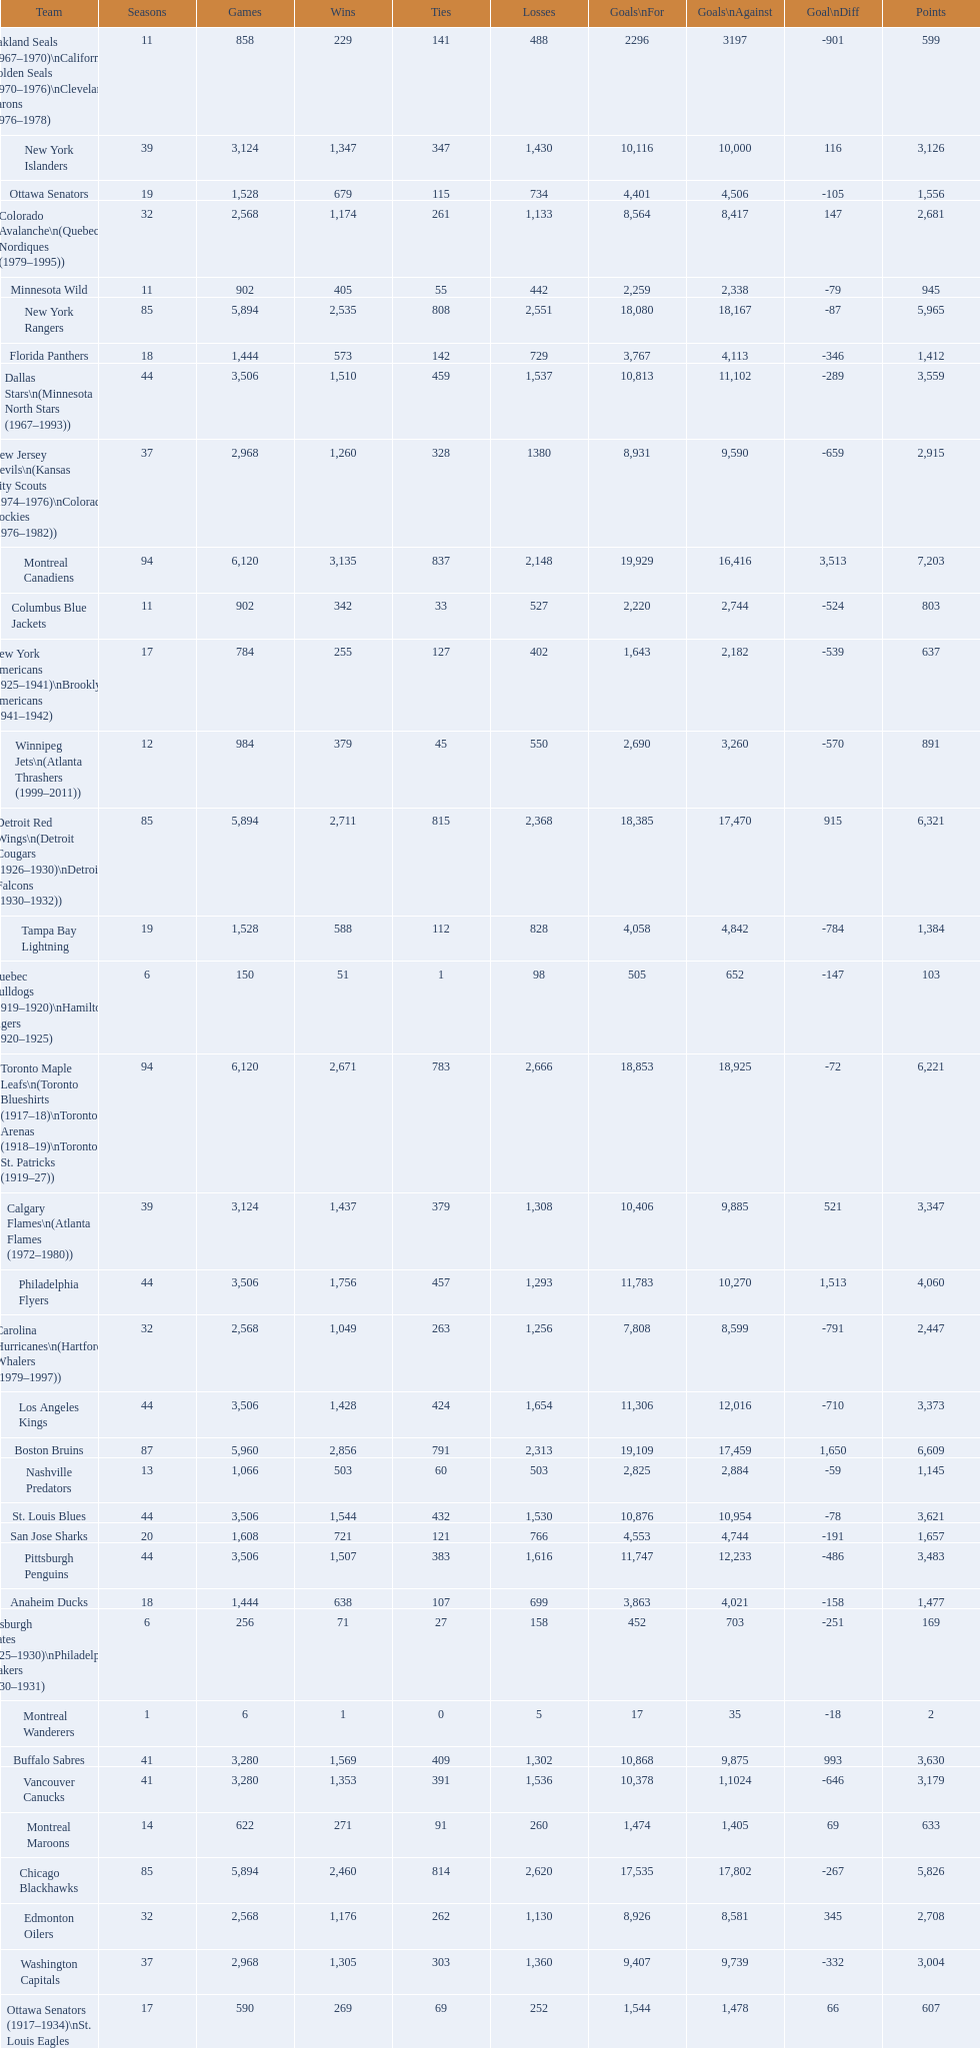Which team had the least points accumulated so far? Montreal Wanderers. 